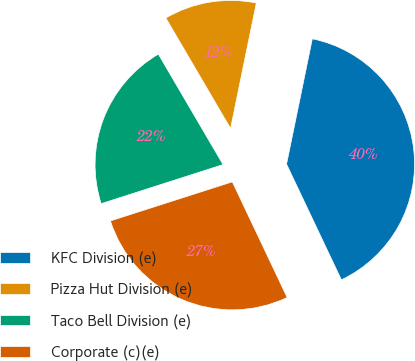Convert chart. <chart><loc_0><loc_0><loc_500><loc_500><pie_chart><fcel>KFC Division (e)<fcel>Pizza Hut Division (e)<fcel>Taco Bell Division (e)<fcel>Corporate (c)(e)<nl><fcel>39.72%<fcel>11.66%<fcel>21.5%<fcel>27.11%<nl></chart> 